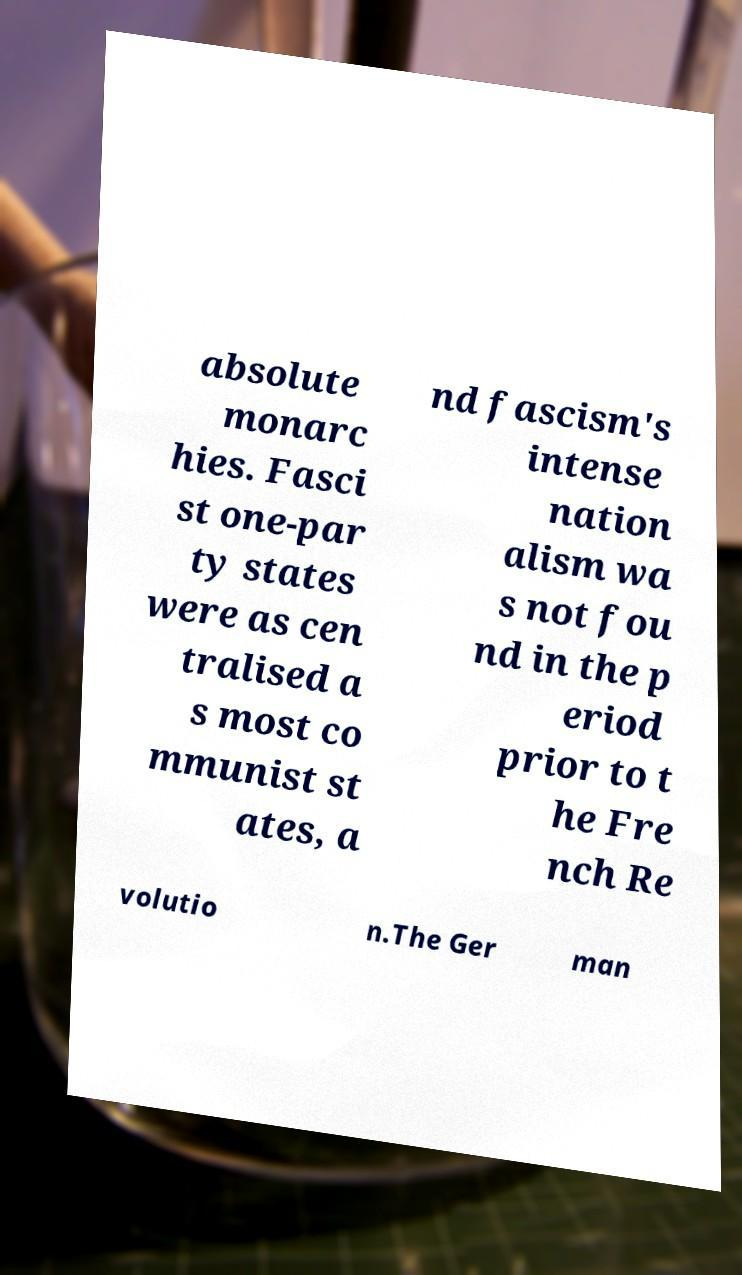Could you assist in decoding the text presented in this image and type it out clearly? absolute monarc hies. Fasci st one-par ty states were as cen tralised a s most co mmunist st ates, a nd fascism's intense nation alism wa s not fou nd in the p eriod prior to t he Fre nch Re volutio n.The Ger man 